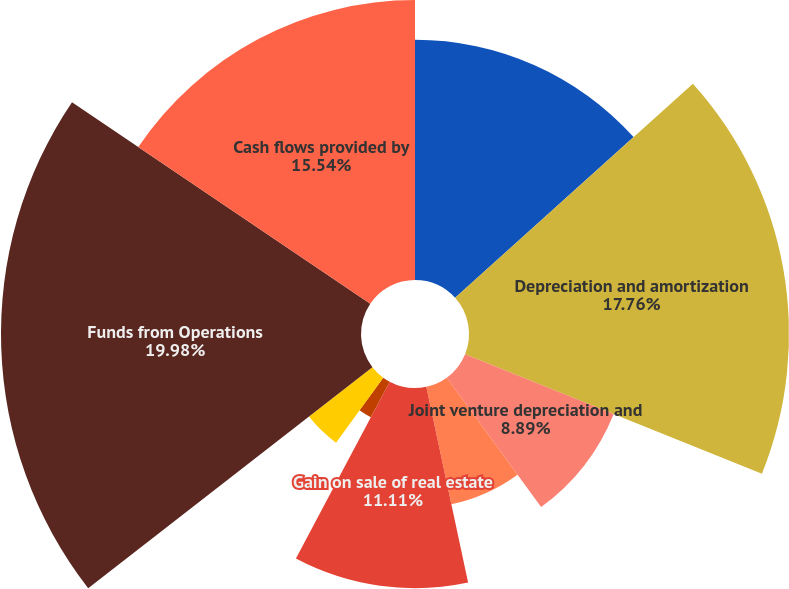Convert chart. <chart><loc_0><loc_0><loc_500><loc_500><pie_chart><fcel>Net income attributable to SL<fcel>Depreciation and amortization<fcel>Joint venture depreciation and<fcel>Net (loss) income attributable<fcel>Gain on sale of real estate<fcel>Equity in net gain on sale of<fcel>Depreciable real estate<fcel>Depreciation on non-rental<fcel>Funds from Operations<fcel>Cash flows provided by<nl><fcel>13.33%<fcel>17.76%<fcel>8.89%<fcel>6.67%<fcel>11.11%<fcel>2.24%<fcel>4.46%<fcel>0.02%<fcel>19.98%<fcel>15.54%<nl></chart> 